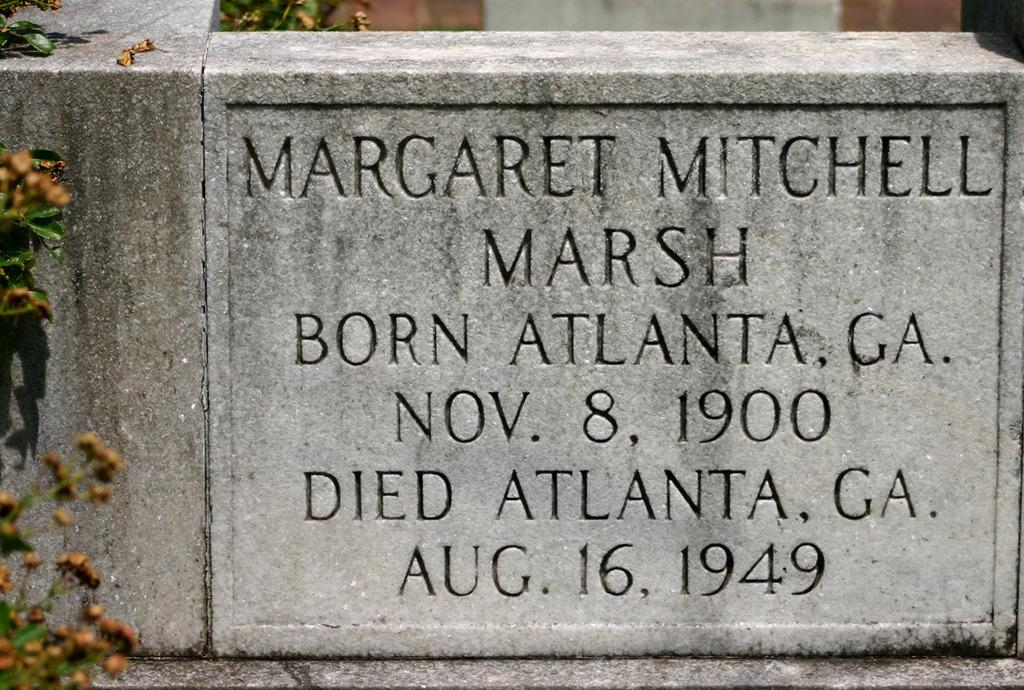What is the main subject in the image? There is a memorial stone in the image. What can be seen on the left side of the image? There are leaves and buds on the left side of the image. Can you see any honey dripping from the memorial stone in the image? There is no honey present in the image. What type of headwear is visible on the memorial stone in the image? There is no headwear visible on the memorial stone in the image. 